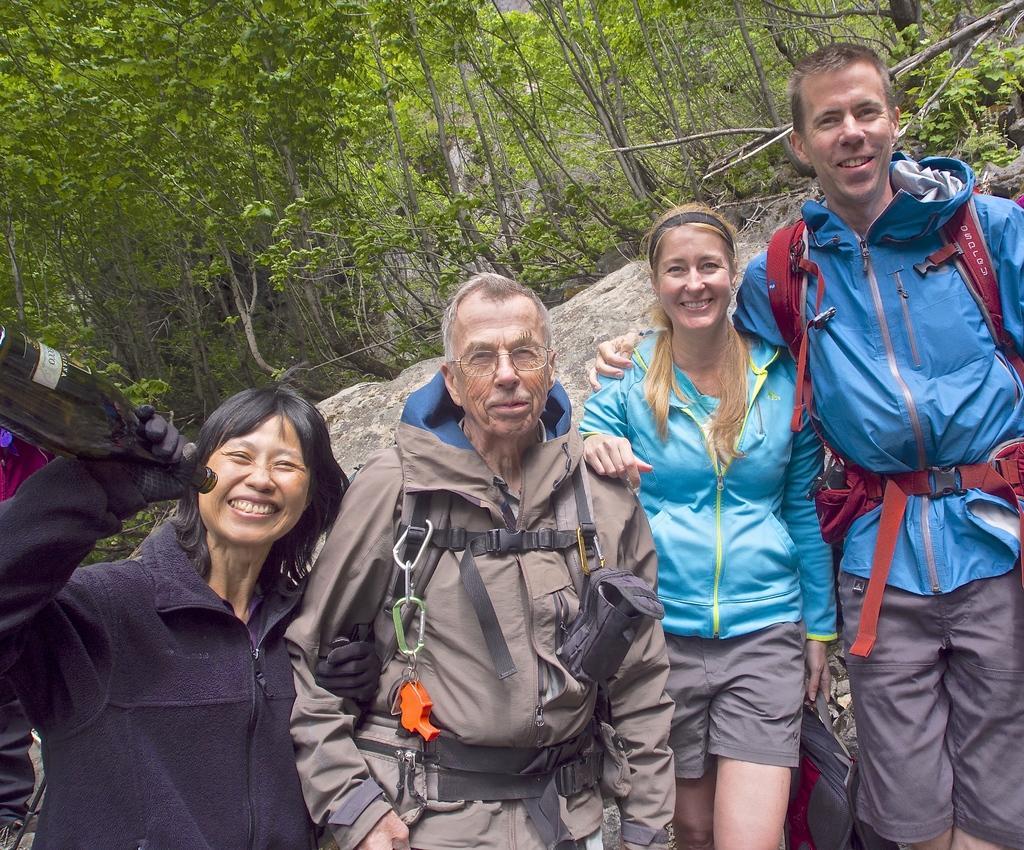Can you describe this image briefly? In this image I can see group of people standing. In front the person is wearing brown color dress, background I can see the rock and few trees in green color. 